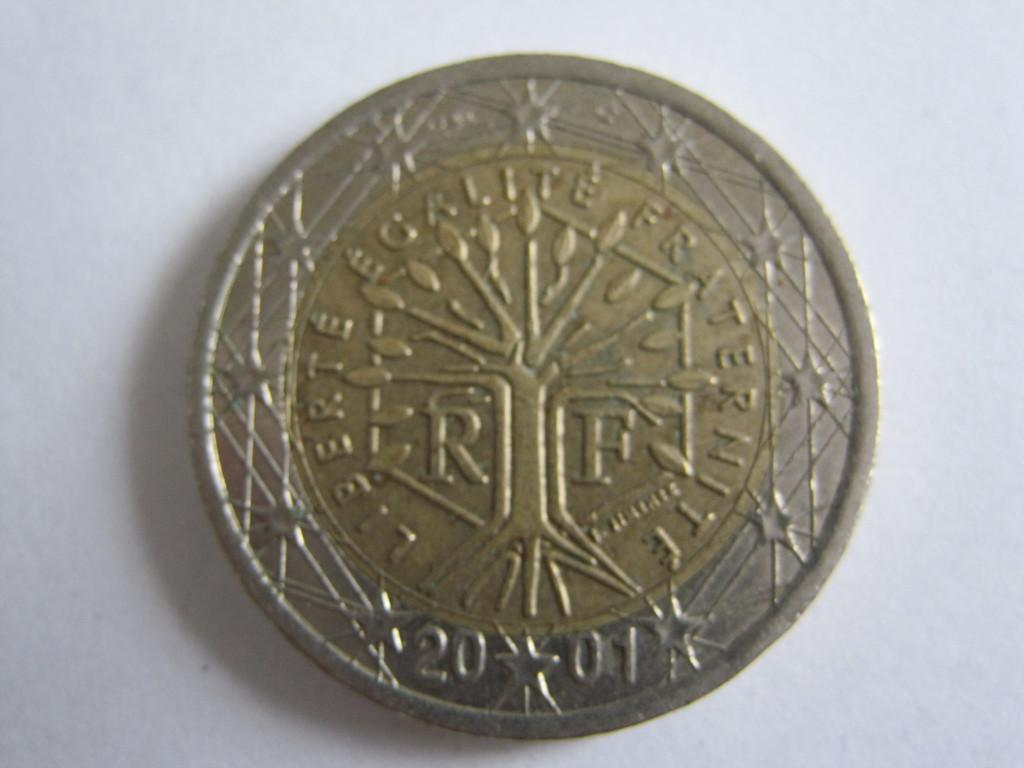<image>
Relay a brief, clear account of the picture shown. A coin from the year 2001 is both gold and silver color. 